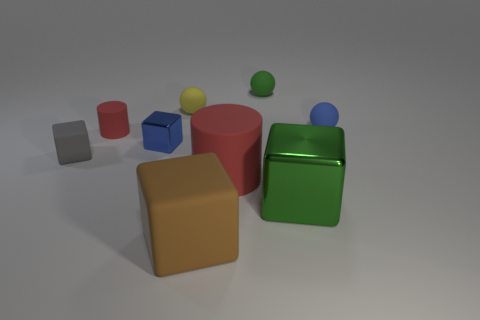Subtract all red cubes. Subtract all red balls. How many cubes are left? 4 Add 1 tiny yellow blocks. How many objects exist? 10 Subtract all balls. How many objects are left? 6 Subtract 1 blue cubes. How many objects are left? 8 Subtract all large red metallic objects. Subtract all green objects. How many objects are left? 7 Add 5 green cubes. How many green cubes are left? 6 Add 1 big metal things. How many big metal things exist? 2 